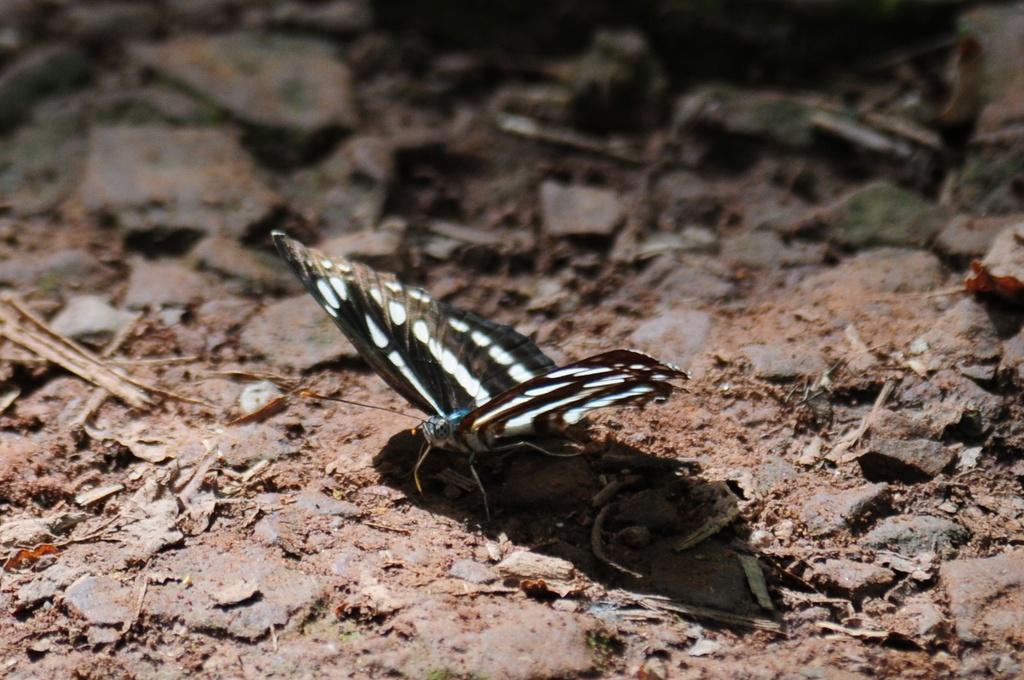In one or two sentences, can you explain what this image depicts? In this image I can see a butterfly on the ground. This image is taken may be in the evening. 